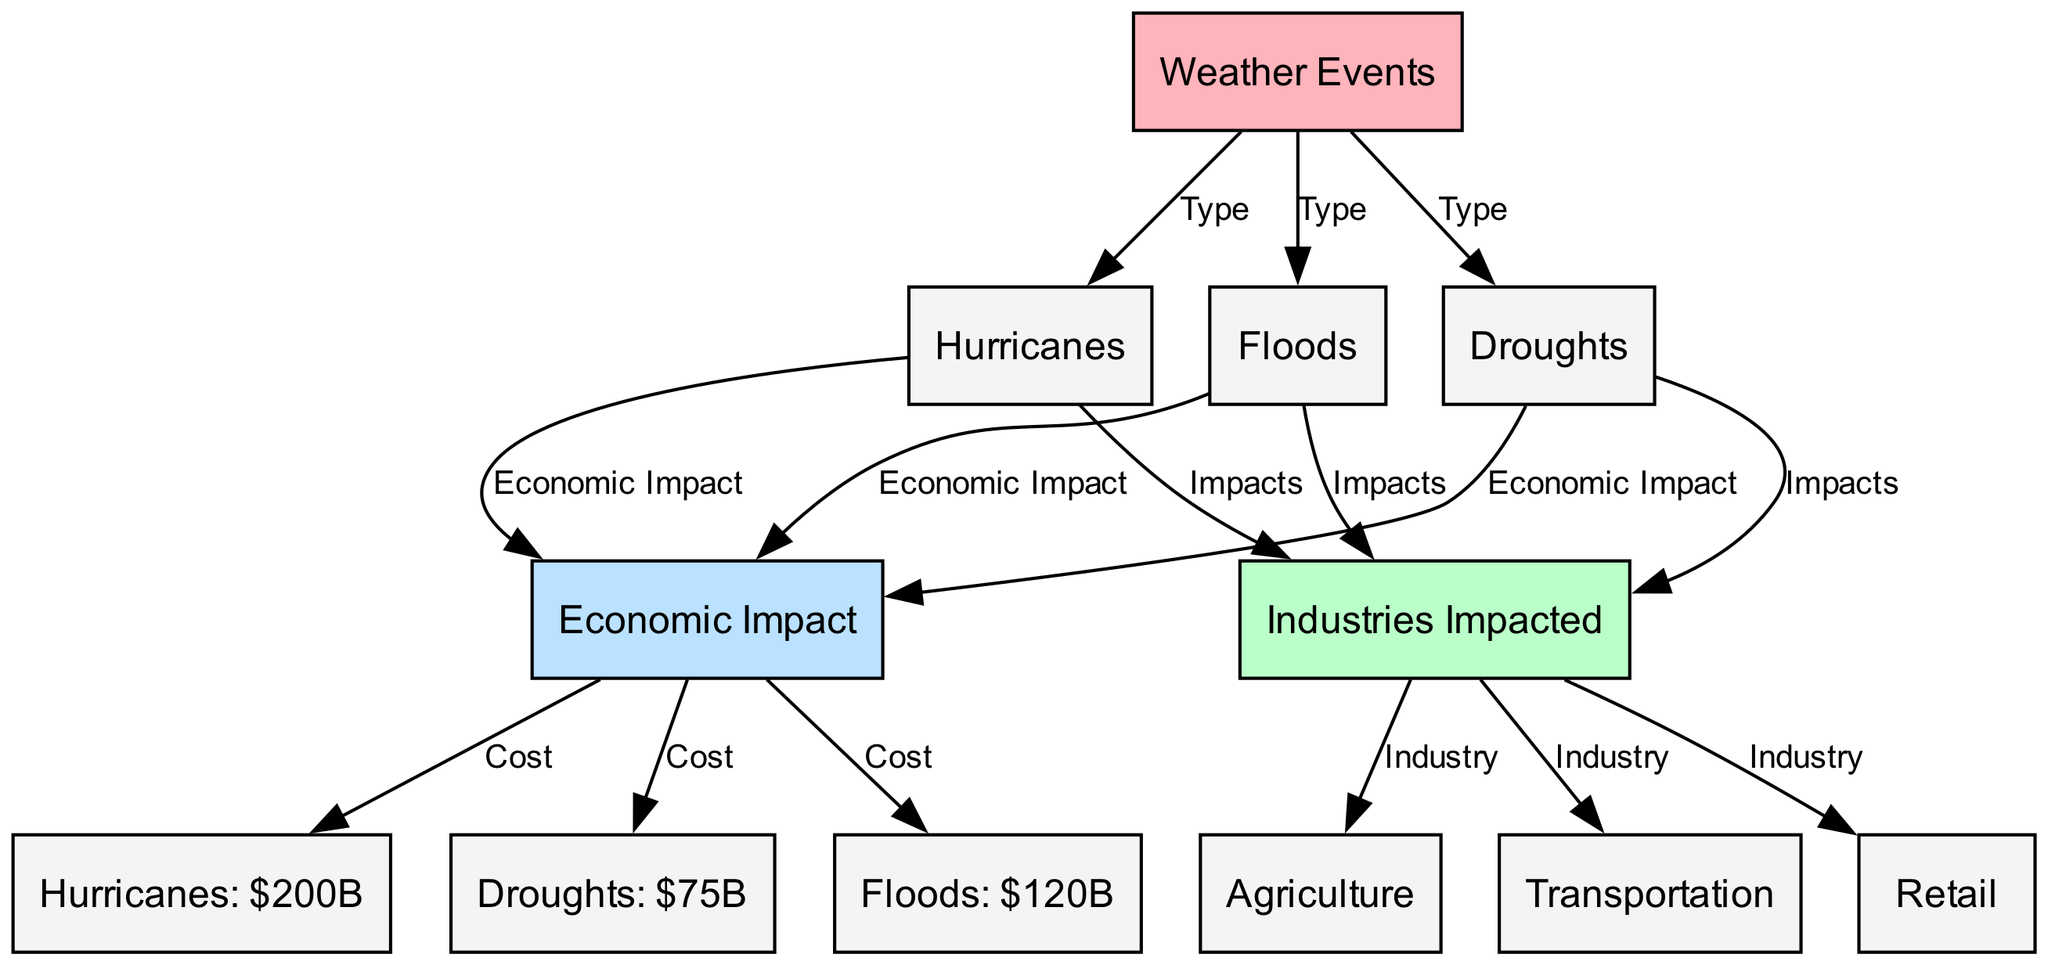What are the types of weather events illustrated in the diagram? The diagram lists three types of weather events, which are directly connected to the "Weather Events" node. These are "Hurricanes," "Droughts," and "Floods."
Answer: Hurricanes, Droughts, Floods What is the total economic loss due to hurricanes? From the diagram, the "Hurricanes" node connects to the "Economic Impact," which further shows a cost of "$200B" for hurricanes.
Answer: $200B Which industry is impacted the most by floods? The diagram shows that "Floods" affect multiple industries, but it does not specify an amount for the impact on each. The industry nodes connected include "Agriculture," "Transportation," and "Retail." Therefore, the answer does not specify a single industry as the most impacted.
Answer: Not specified How much financial loss is associated with droughts? The "Droughts" node connects to the "Economic Impact," which indicates a financial loss of "$75B" attributed to droughts.
Answer: $75B What is the total economic loss reported for floods? The "Floods" node connects to the "Economic Impact," which shows a cost of "$120B" specifically for floods.
Answer: $120B Which three industries are impacted by hurricanes? The "Hurricanes" node connects to the "Industries Impacted," which then points to three specific industries: "Agriculture," "Transportation," and "Retail."
Answer: Agriculture, Transportation, Retail If you combine the losses from droughts and floods, what is the total? To find the total losses from both droughts and floods, add the costs: $75B (droughts) + $120B (floods) = $195B.
Answer: $195B What color is used for nodes representing industries impacted? The color scheme in the diagram indicates that "Industries Impacted" nodes are colored in light green, denoted by the hex code #BAFFC9.
Answer: Light green How many edges connect the economic impact to the types of weather events? Observing the diagram, there are three types of weather events (hurricanes, droughts, floods), each connected by one edge to the "Economic Impact" node, resulting in a total of three edges.
Answer: 3 